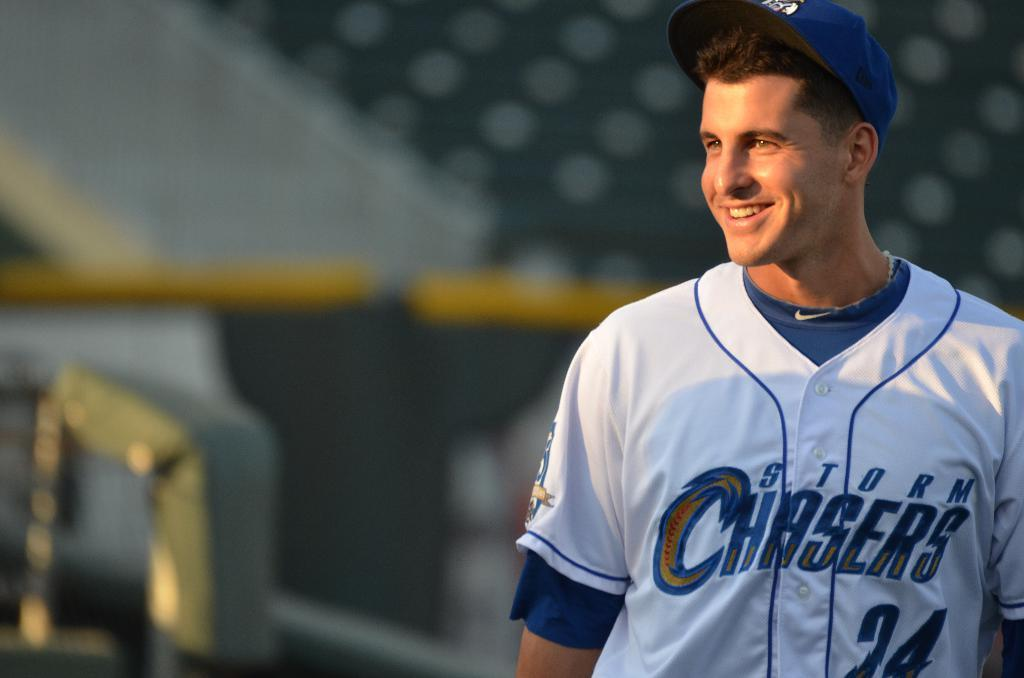<image>
Describe the image concisely. A baseball player in a Storm Chasers uniform wears a sunny smile. 